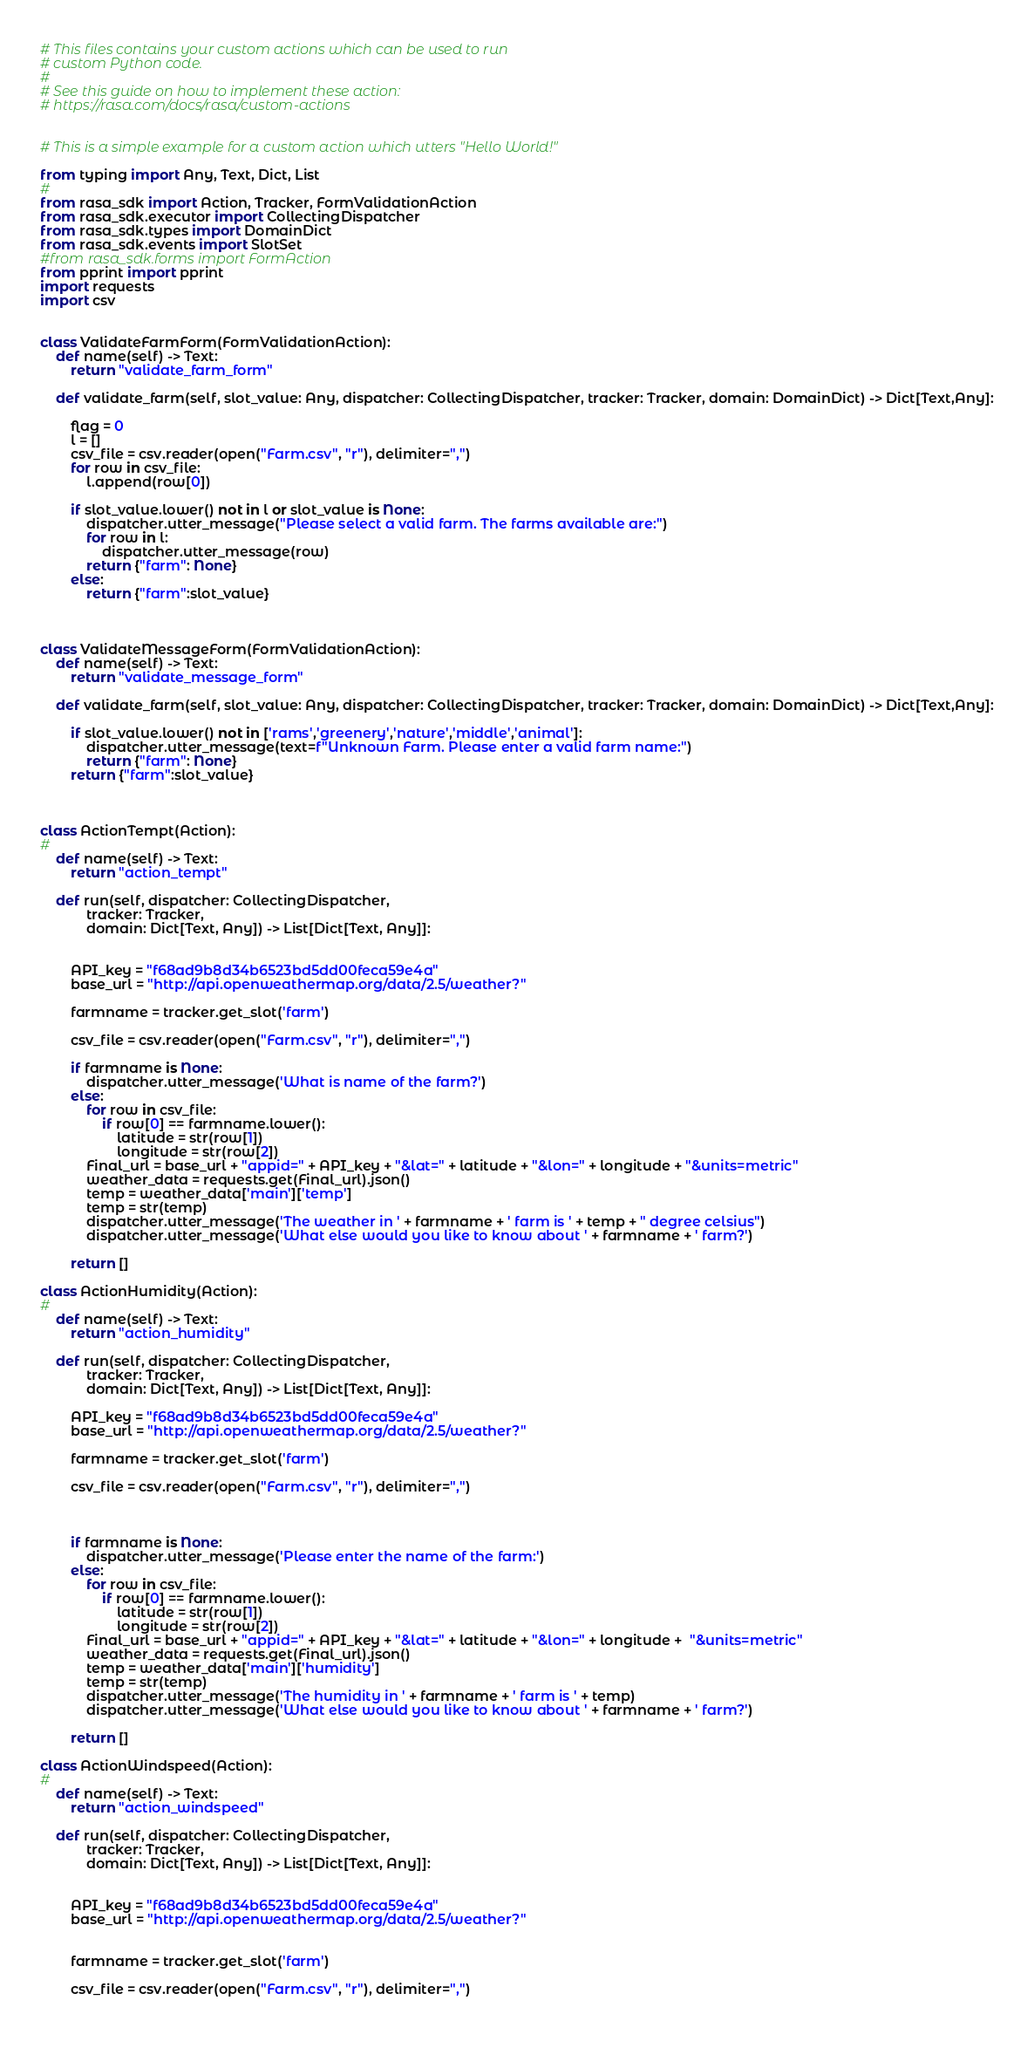<code> <loc_0><loc_0><loc_500><loc_500><_Python_># This files contains your custom actions which can be used to run
# custom Python code.
#
# See this guide on how to implement these action:
# https://rasa.com/docs/rasa/custom-actions


# This is a simple example for a custom action which utters "Hello World!"

from typing import Any, Text, Dict, List
#
from rasa_sdk import Action, Tracker, FormValidationAction
from rasa_sdk.executor import CollectingDispatcher
from rasa_sdk.types import DomainDict
from rasa_sdk.events import SlotSet
#from rasa_sdk.forms import FormAction
from pprint import pprint
import requests
import csv


class ValidateFarmForm(FormValidationAction):
    def name(self) -> Text:
        return "validate_farm_form"
    
    def validate_farm(self, slot_value: Any, dispatcher: CollectingDispatcher, tracker: Tracker, domain: DomainDict) -> Dict[Text,Any]:

        flag = 0
        l = []
        csv_file = csv.reader(open("Farm.csv", "r"), delimiter=",")
        for row in csv_file:
            l.append(row[0])
        
        if slot_value.lower() not in l or slot_value is None:
            dispatcher.utter_message("Please select a valid farm. The farms available are:")
            for row in l:
                dispatcher.utter_message(row)
            return {"farm": None}
        else:
            return {"farm":slot_value}  



class ValidateMessageForm(FormValidationAction):
    def name(self) -> Text:
        return "validate_message_form"
    
    def validate_farm(self, slot_value: Any, dispatcher: CollectingDispatcher, tracker: Tracker, domain: DomainDict) -> Dict[Text,Any]:

        if slot_value.lower() not in ['rams','greenery','nature','middle','animal']:
            dispatcher.utter_message(text=f"Unknown Farm. Please enter a valid farm name:")
            return {"farm": None}
        return {"farm":slot_value}



class ActionTempt(Action):
#
    def name(self) -> Text:
        return "action_tempt"

    def run(self, dispatcher: CollectingDispatcher,
            tracker: Tracker,
            domain: Dict[Text, Any]) -> List[Dict[Text, Any]]:

 
        API_key = "f68ad9b8d34b6523bd5dd00feca59e4a"
        base_url = "http://api.openweathermap.org/data/2.5/weather?"

        farmname = tracker.get_slot('farm')
        
        csv_file = csv.reader(open("Farm.csv", "r"), delimiter=",")

        if farmname is None:
            dispatcher.utter_message('What is name of the farm?')
        else:
            for row in csv_file:
                if row[0] == farmname.lower():
                    latitude = str(row[1])
                    longitude = str(row[2])
            Final_url = base_url + "appid=" + API_key + "&lat=" + latitude + "&lon=" + longitude + "&units=metric"
            weather_data = requests.get(Final_url).json()    
            temp = weather_data['main']['temp']
            temp = str(temp)
            dispatcher.utter_message('The weather in ' + farmname + ' farm is ' + temp + " degree celsius") 
            dispatcher.utter_message('What else would you like to know about ' + farmname + ' farm?')

        return []

class ActionHumidity(Action):
#
    def name(self) -> Text:
        return "action_humidity"

    def run(self, dispatcher: CollectingDispatcher,
            tracker: Tracker,
            domain: Dict[Text, Any]) -> List[Dict[Text, Any]]:

        API_key = "f68ad9b8d34b6523bd5dd00feca59e4a"
        base_url = "http://api.openweathermap.org/data/2.5/weather?"

        farmname = tracker.get_slot('farm')
        
        csv_file = csv.reader(open("Farm.csv", "r"), delimiter=",")
    
        
        
        if farmname is None:
            dispatcher.utter_message('Please enter the name of the farm:')
        else:
            for row in csv_file:
                if row[0] == farmname.lower():
                    latitude = str(row[1])
                    longitude = str(row[2])
            Final_url = base_url + "appid=" + API_key + "&lat=" + latitude + "&lon=" + longitude +  "&units=metric"
            weather_data = requests.get(Final_url).json()    
            temp = weather_data['main']['humidity']
            temp = str(temp)
            dispatcher.utter_message('The humidity in ' + farmname + ' farm is ' + temp) 
            dispatcher.utter_message('What else would you like to know about ' + farmname + ' farm?')

        return []

class ActionWindspeed(Action):
#
    def name(self) -> Text:
        return "action_windspeed"

    def run(self, dispatcher: CollectingDispatcher,
            tracker: Tracker,
            domain: Dict[Text, Any]) -> List[Dict[Text, Any]]:


        API_key = "f68ad9b8d34b6523bd5dd00feca59e4a"
        base_url = "http://api.openweathermap.org/data/2.5/weather?"
        

        farmname = tracker.get_slot('farm')

        csv_file = csv.reader(open("Farm.csv", "r"), delimiter=",")
        
</code> 